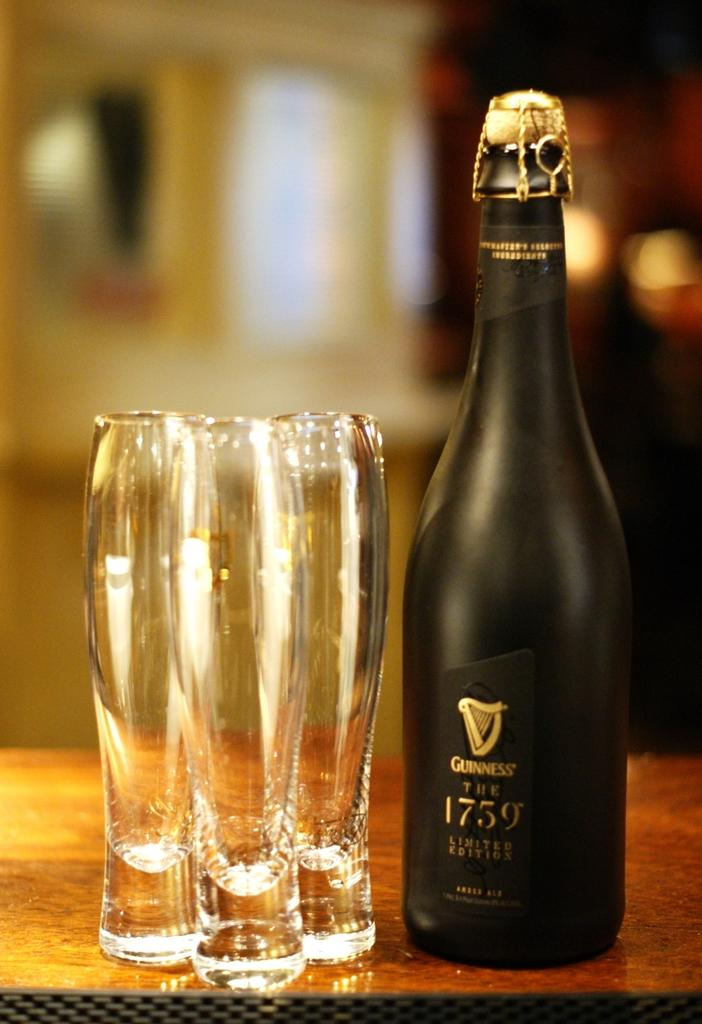What type of objects can be seen in the image? There are glasses and a black color bottle in the image. What is the color of the surface on which the objects are placed? The objects are on a brown color surface. How would you describe the background of the image? The background of the image is blurred. How many ducks are playing with the balls in the image? There are no ducks or balls present in the image. What type of motion can be seen in the image? There is no motion visible in the image; the objects are stationary on the brown surface. 